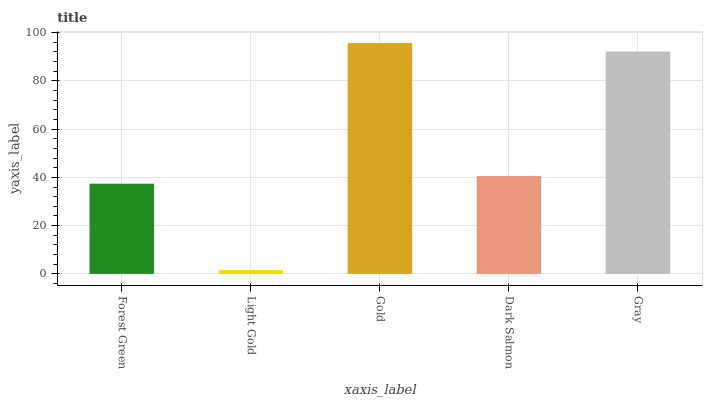Is Light Gold the minimum?
Answer yes or no. Yes. Is Gold the maximum?
Answer yes or no. Yes. Is Gold the minimum?
Answer yes or no. No. Is Light Gold the maximum?
Answer yes or no. No. Is Gold greater than Light Gold?
Answer yes or no. Yes. Is Light Gold less than Gold?
Answer yes or no. Yes. Is Light Gold greater than Gold?
Answer yes or no. No. Is Gold less than Light Gold?
Answer yes or no. No. Is Dark Salmon the high median?
Answer yes or no. Yes. Is Dark Salmon the low median?
Answer yes or no. Yes. Is Gold the high median?
Answer yes or no. No. Is Light Gold the low median?
Answer yes or no. No. 